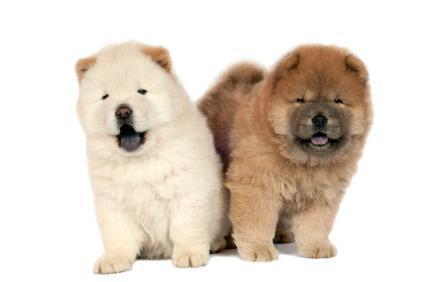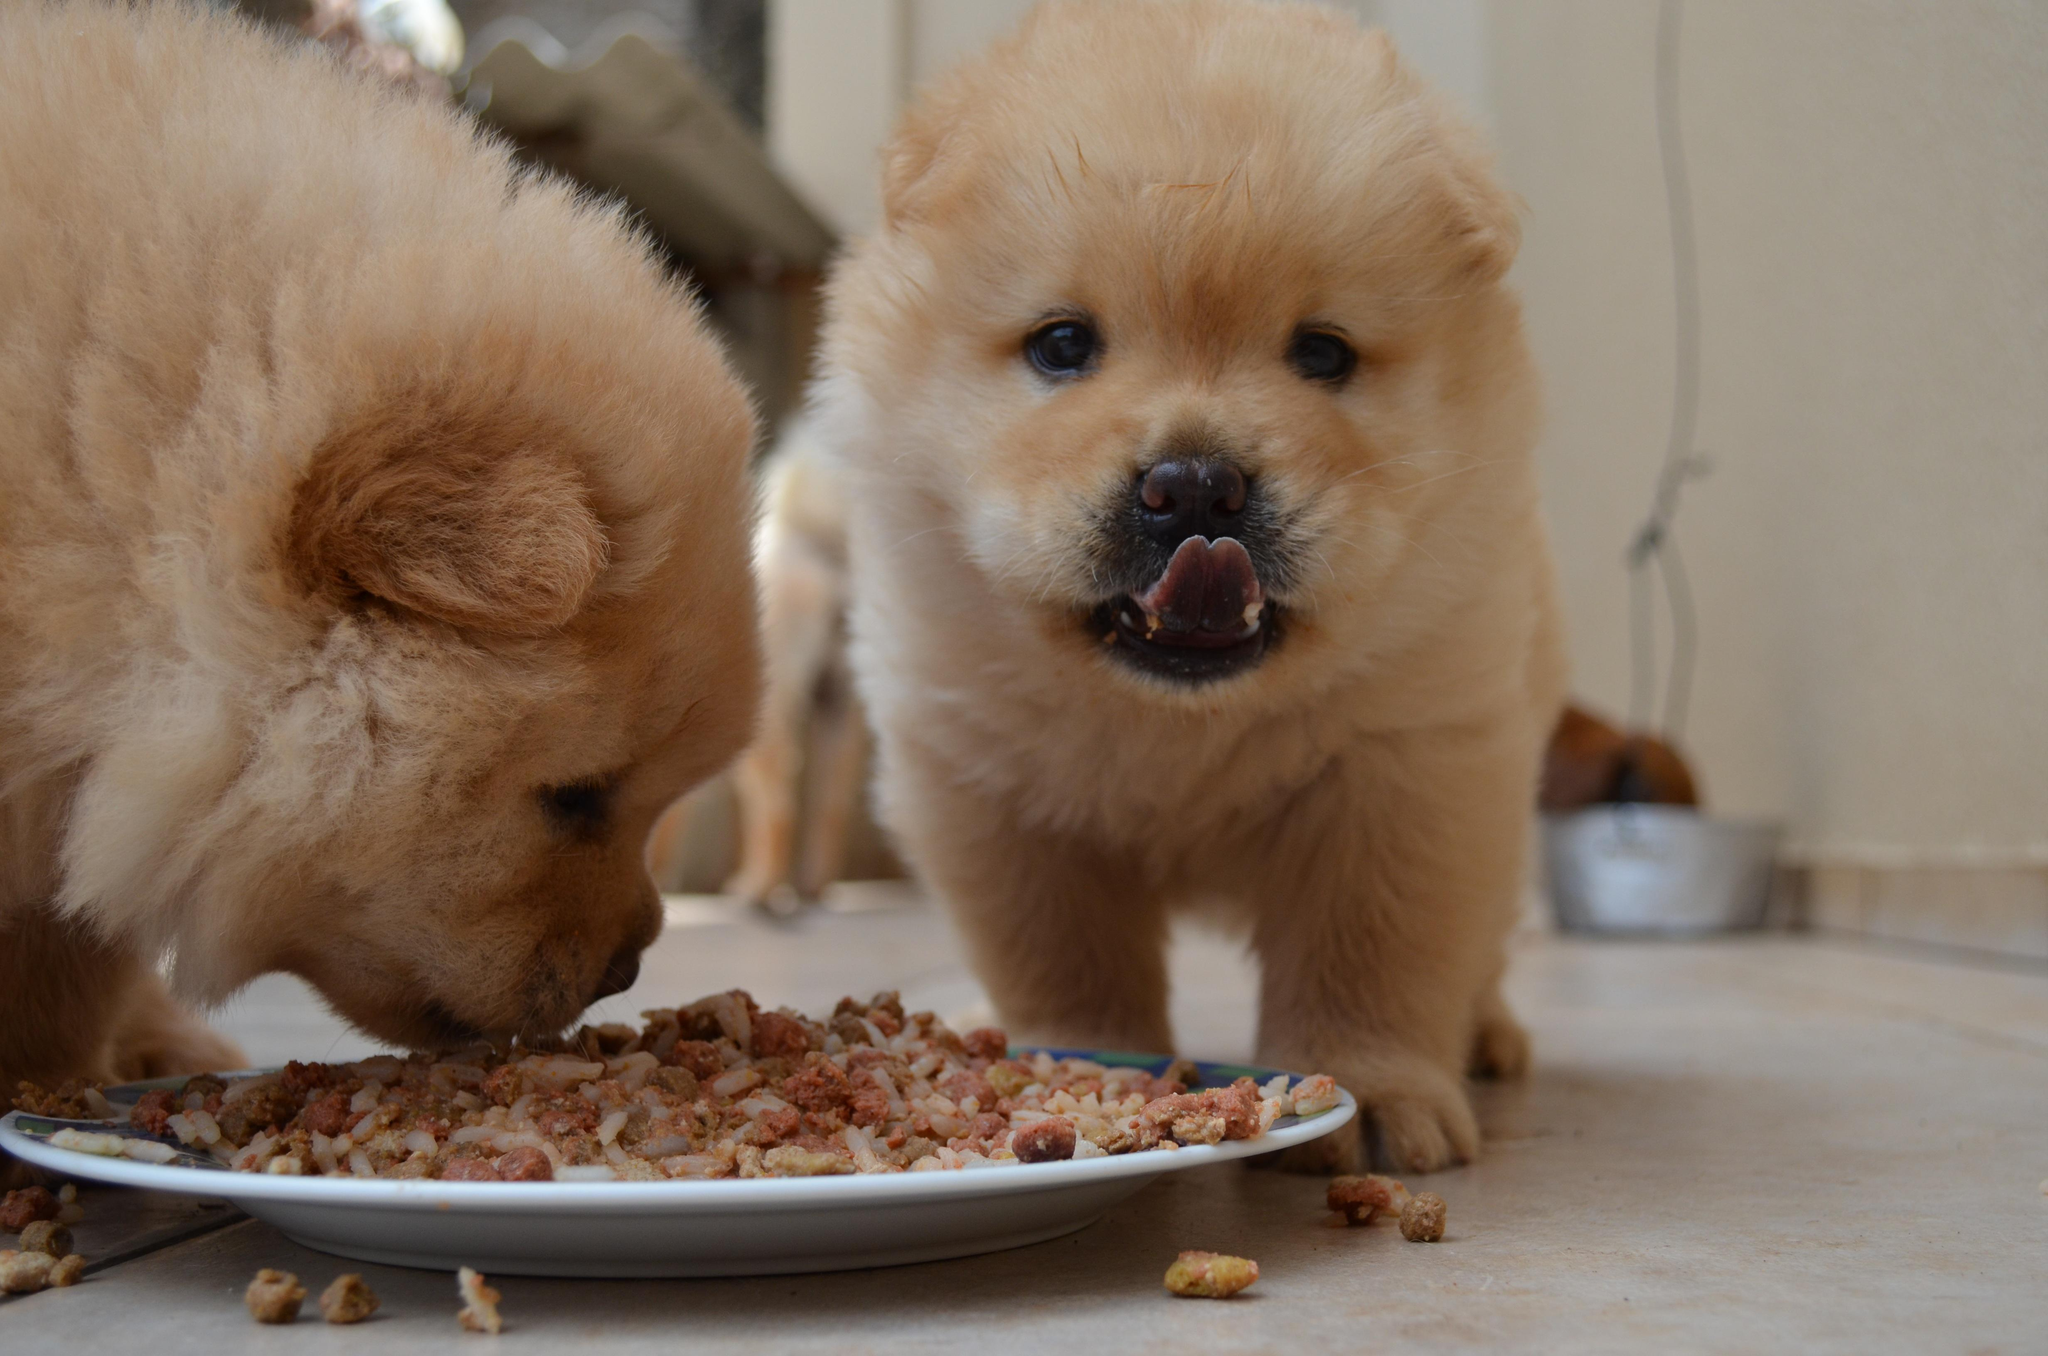The first image is the image on the left, the second image is the image on the right. Analyze the images presented: Is the assertion "One of the images contains at least three dogs." valid? Answer yes or no. No. 